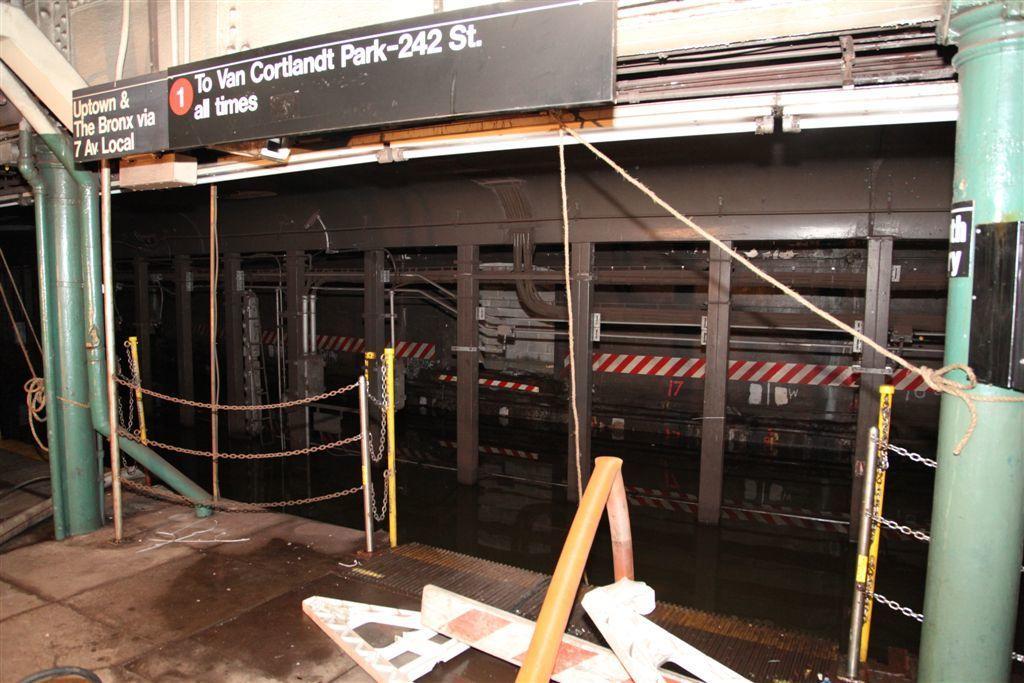Describe this image in one or two sentences. This is a building. 